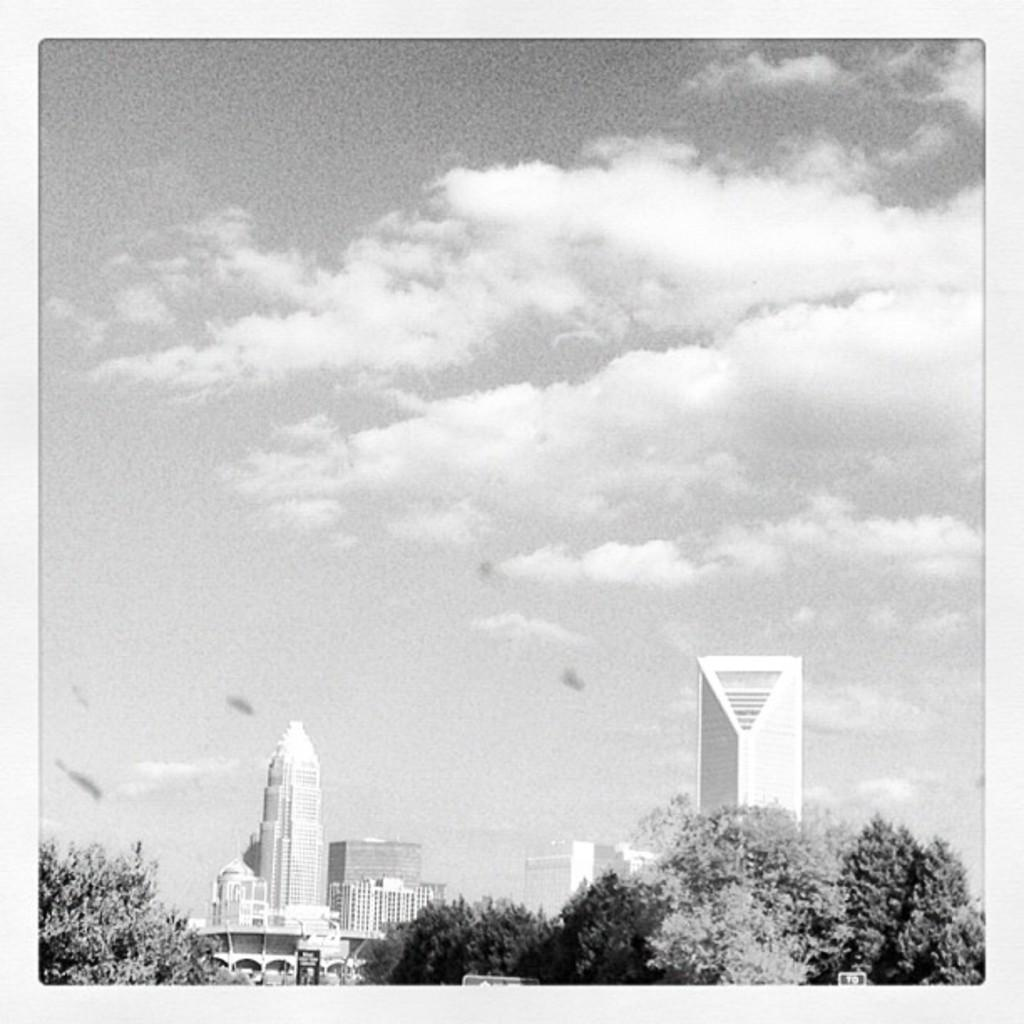What types of structures are located at the bottom of the image? There are buildings and trees at the bottom of the image. What can be seen in the background of the image? The sky is visible in the background of the image. What type of trick can be seen being performed by the mountain in the image? There is no mountain present in the image, so no trick can be observed. 